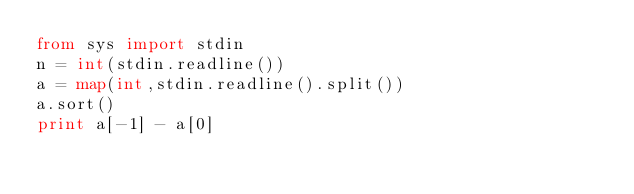Convert code to text. <code><loc_0><loc_0><loc_500><loc_500><_Python_>from sys import stdin
n = int(stdin.readline())
a = map(int,stdin.readline().split())
a.sort()
print a[-1] - a[0]</code> 